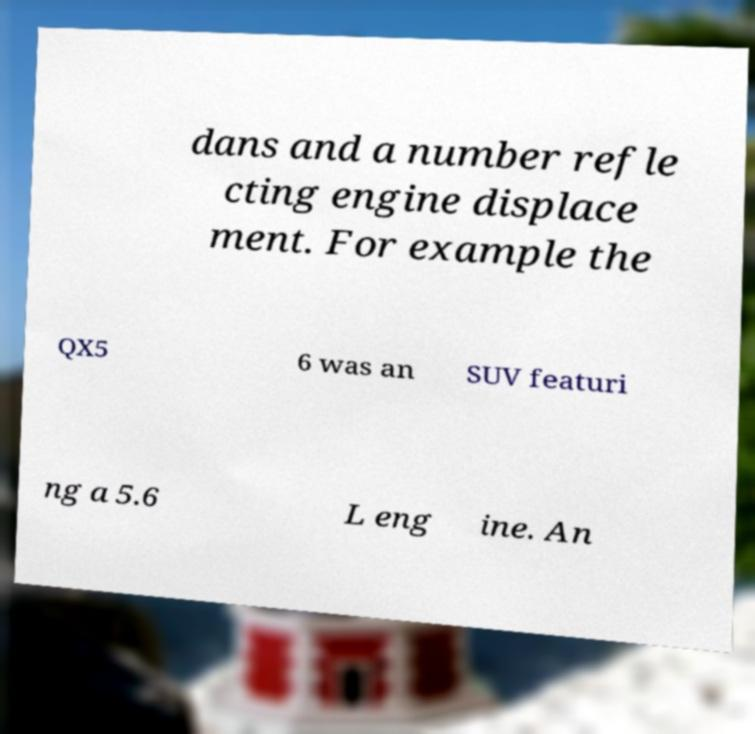Can you read and provide the text displayed in the image?This photo seems to have some interesting text. Can you extract and type it out for me? dans and a number refle cting engine displace ment. For example the QX5 6 was an SUV featuri ng a 5.6 L eng ine. An 